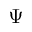Convert formula to latex. <formula><loc_0><loc_0><loc_500><loc_500>\Psi</formula> 